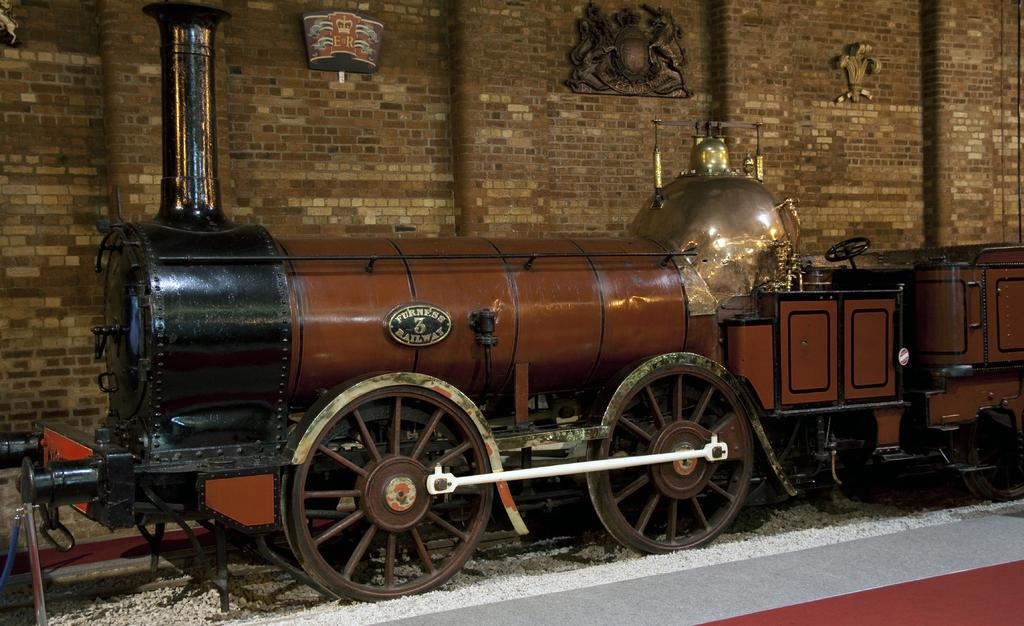What type of toy is present in the image? There is a toy locomotive in the image. What can be seen on the ground in the image? There are white color objects on the ground. What is visible in the background of the image? There is a wall with pillars and frames in the background of the image. What type of texture can be seen on the bottle in the image? There is no bottle present in the image, so it is not possible to determine the texture. 